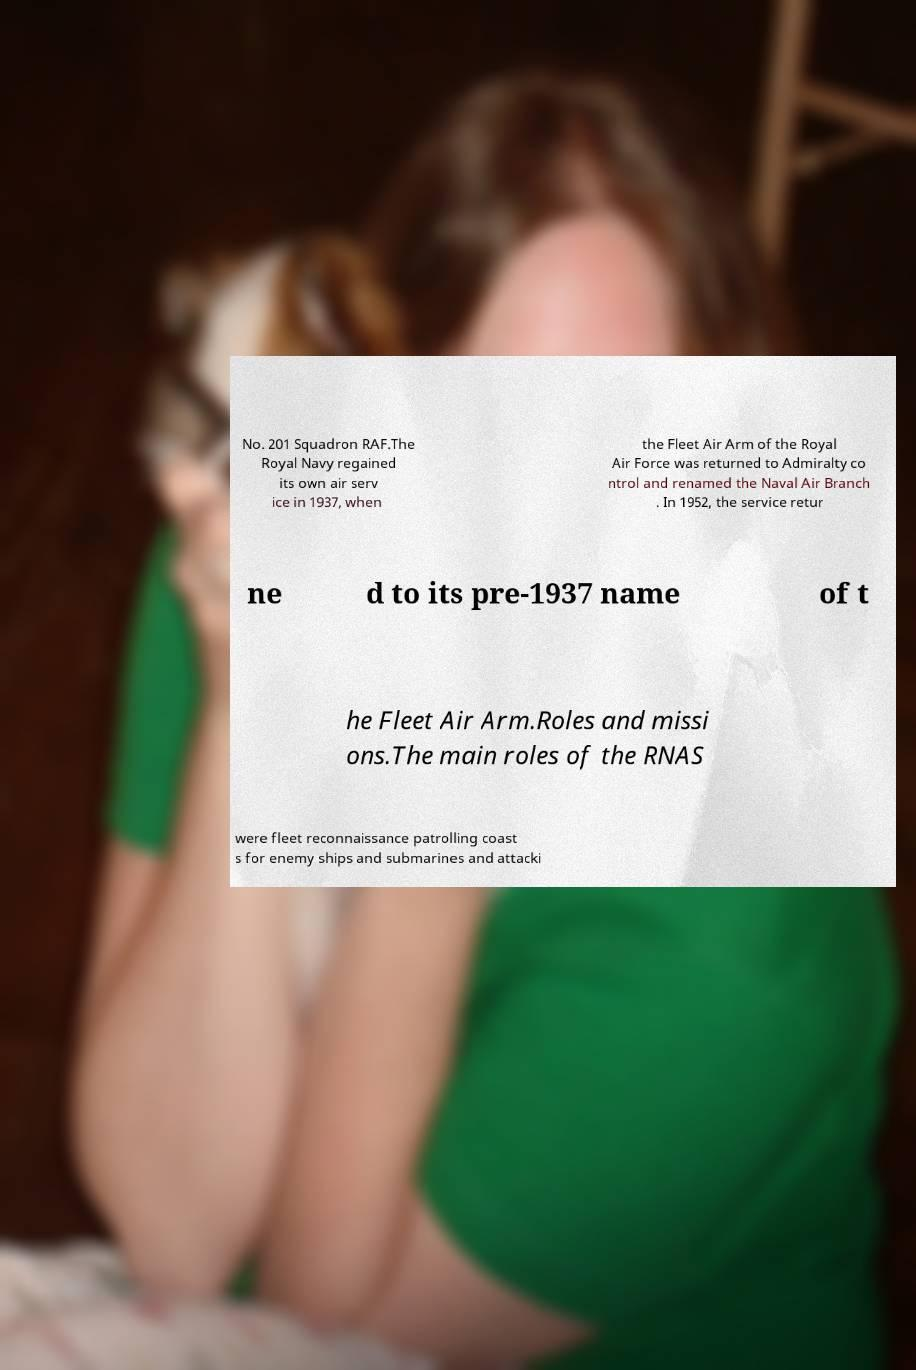For documentation purposes, I need the text within this image transcribed. Could you provide that? No. 201 Squadron RAF.The Royal Navy regained its own air serv ice in 1937, when the Fleet Air Arm of the Royal Air Force was returned to Admiralty co ntrol and renamed the Naval Air Branch . In 1952, the service retur ne d to its pre-1937 name of t he Fleet Air Arm.Roles and missi ons.The main roles of the RNAS were fleet reconnaissance patrolling coast s for enemy ships and submarines and attacki 